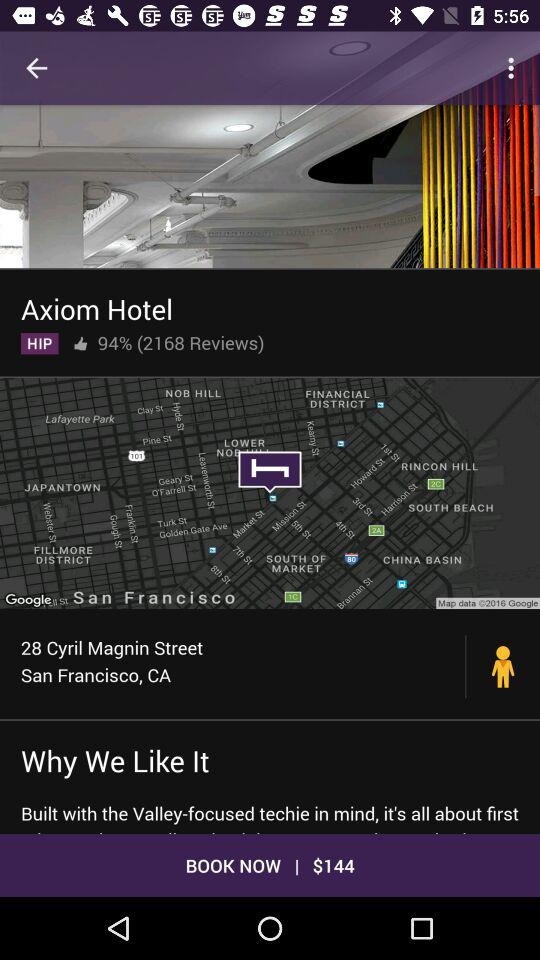How many reviews does Axiom Hotel have?
Answer the question using a single word or phrase. 2168 